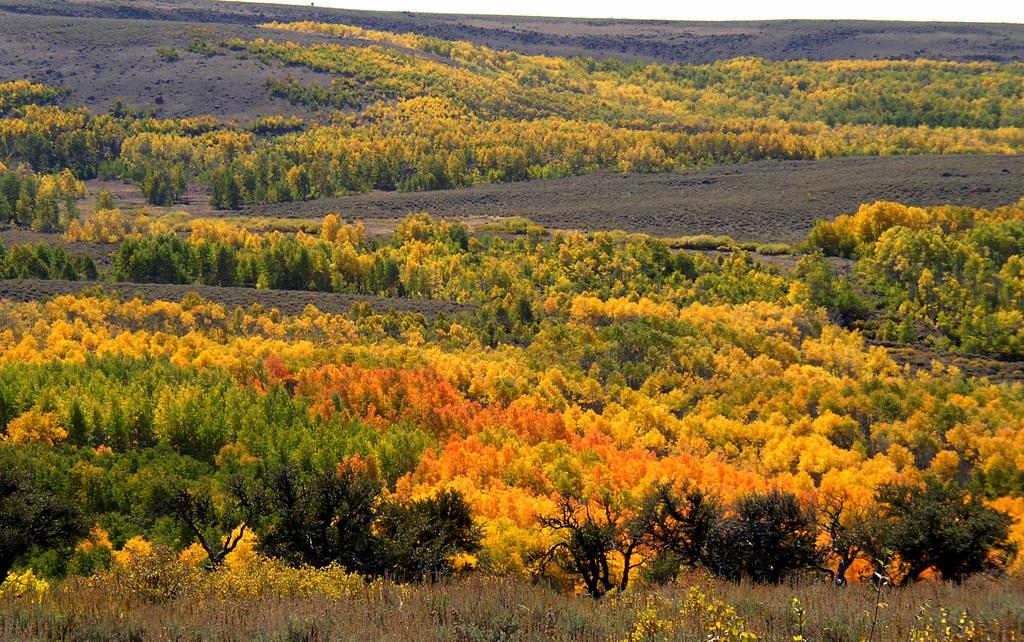What type of vegetation can be seen in the image? There are trees in the image. What is present at the bottom of the image? There is grass at the bottom of the image. Where is the can located in the image? There is no can present in the image. What type of ornament is hanging from the trees in the image? There are no ornaments hanging from the trees in the image; only the trees and grass are present. 